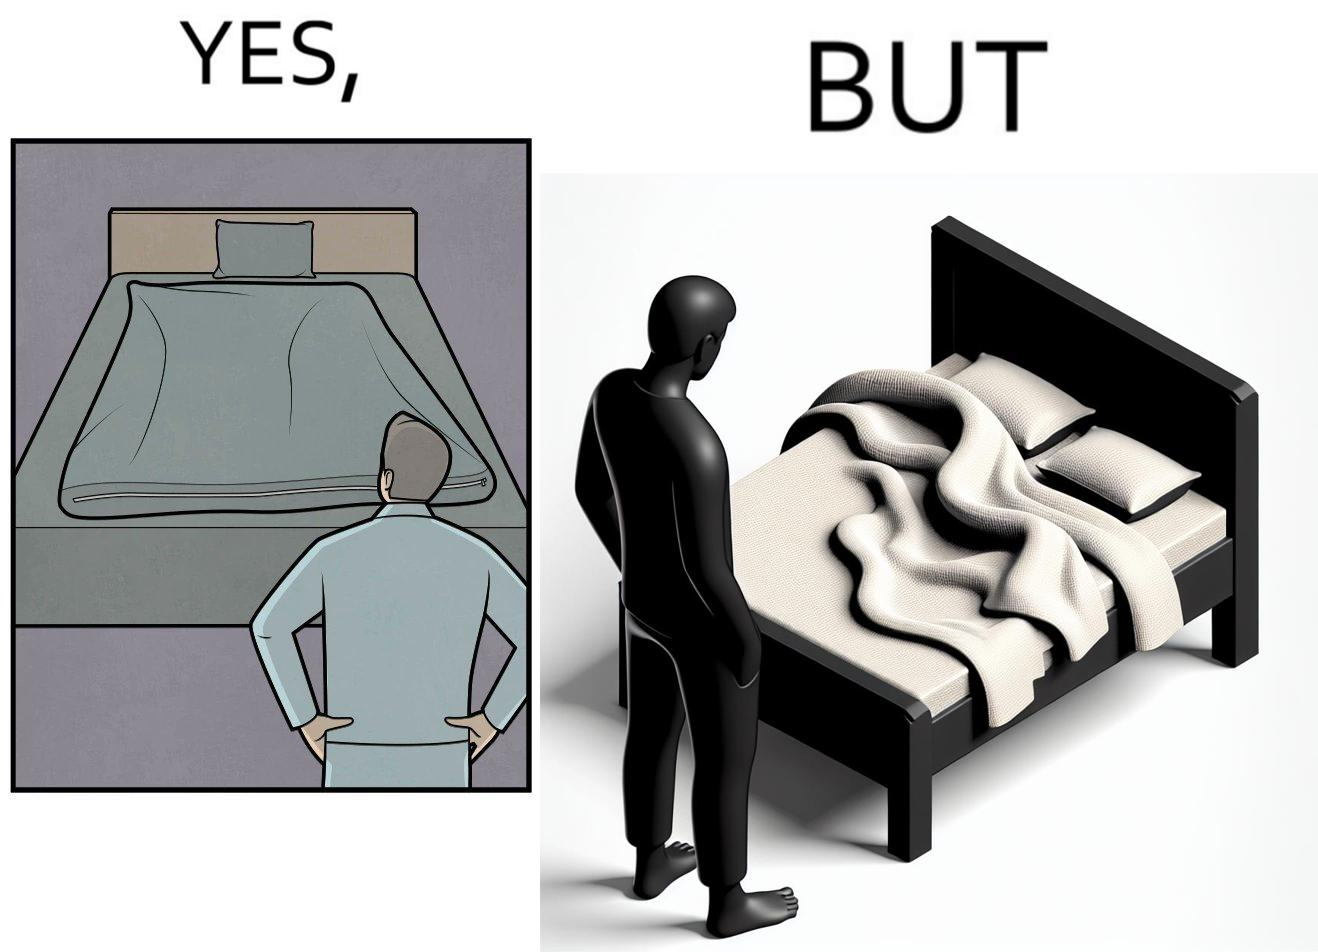Does this image contain satire or humor? Yes, this image is satirical. 